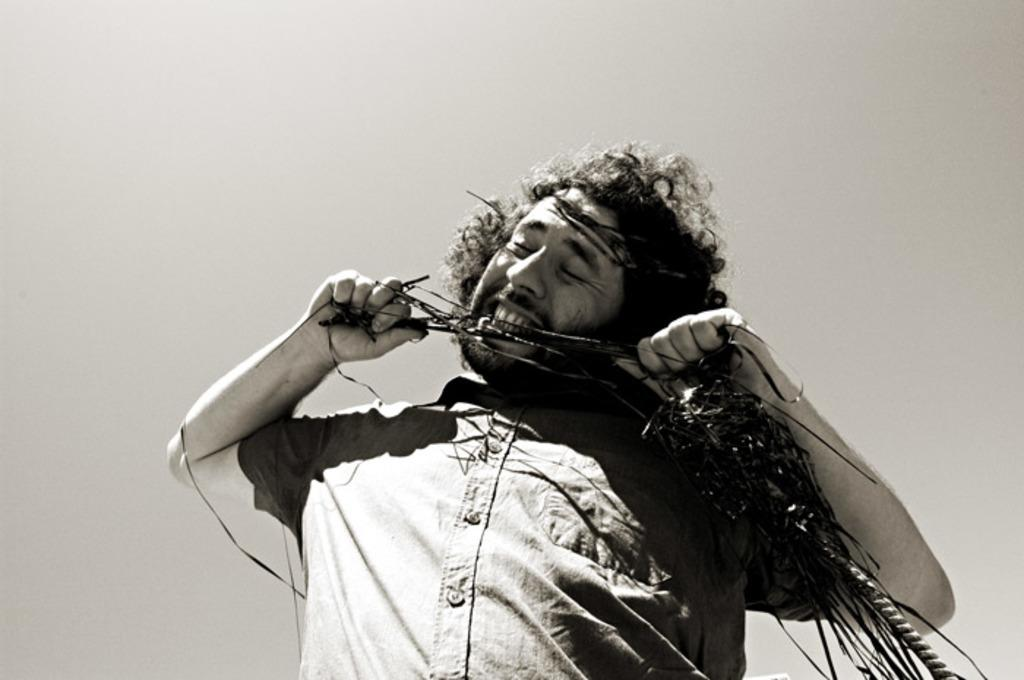What is the color scheme of the image? The image is black and white. Can you describe the person in the image? There is a man standing in the image. What is the man doing in the image? The man appears to be biting an audio cassette tape. What type of boat can be seen in the image? There is no boat present in the image. What discovery was made by the man in the image? There is no indication of a discovery being made in the image. 